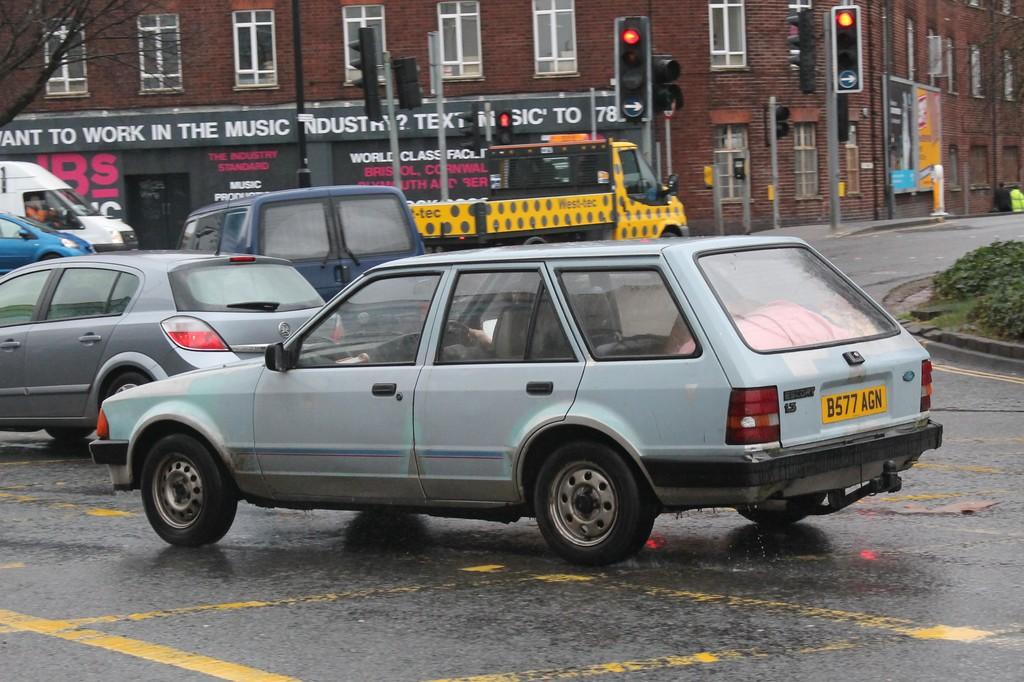<image>
Provide a brief description of the given image. A car with the license plate B577 AGN is driving in traffic. 